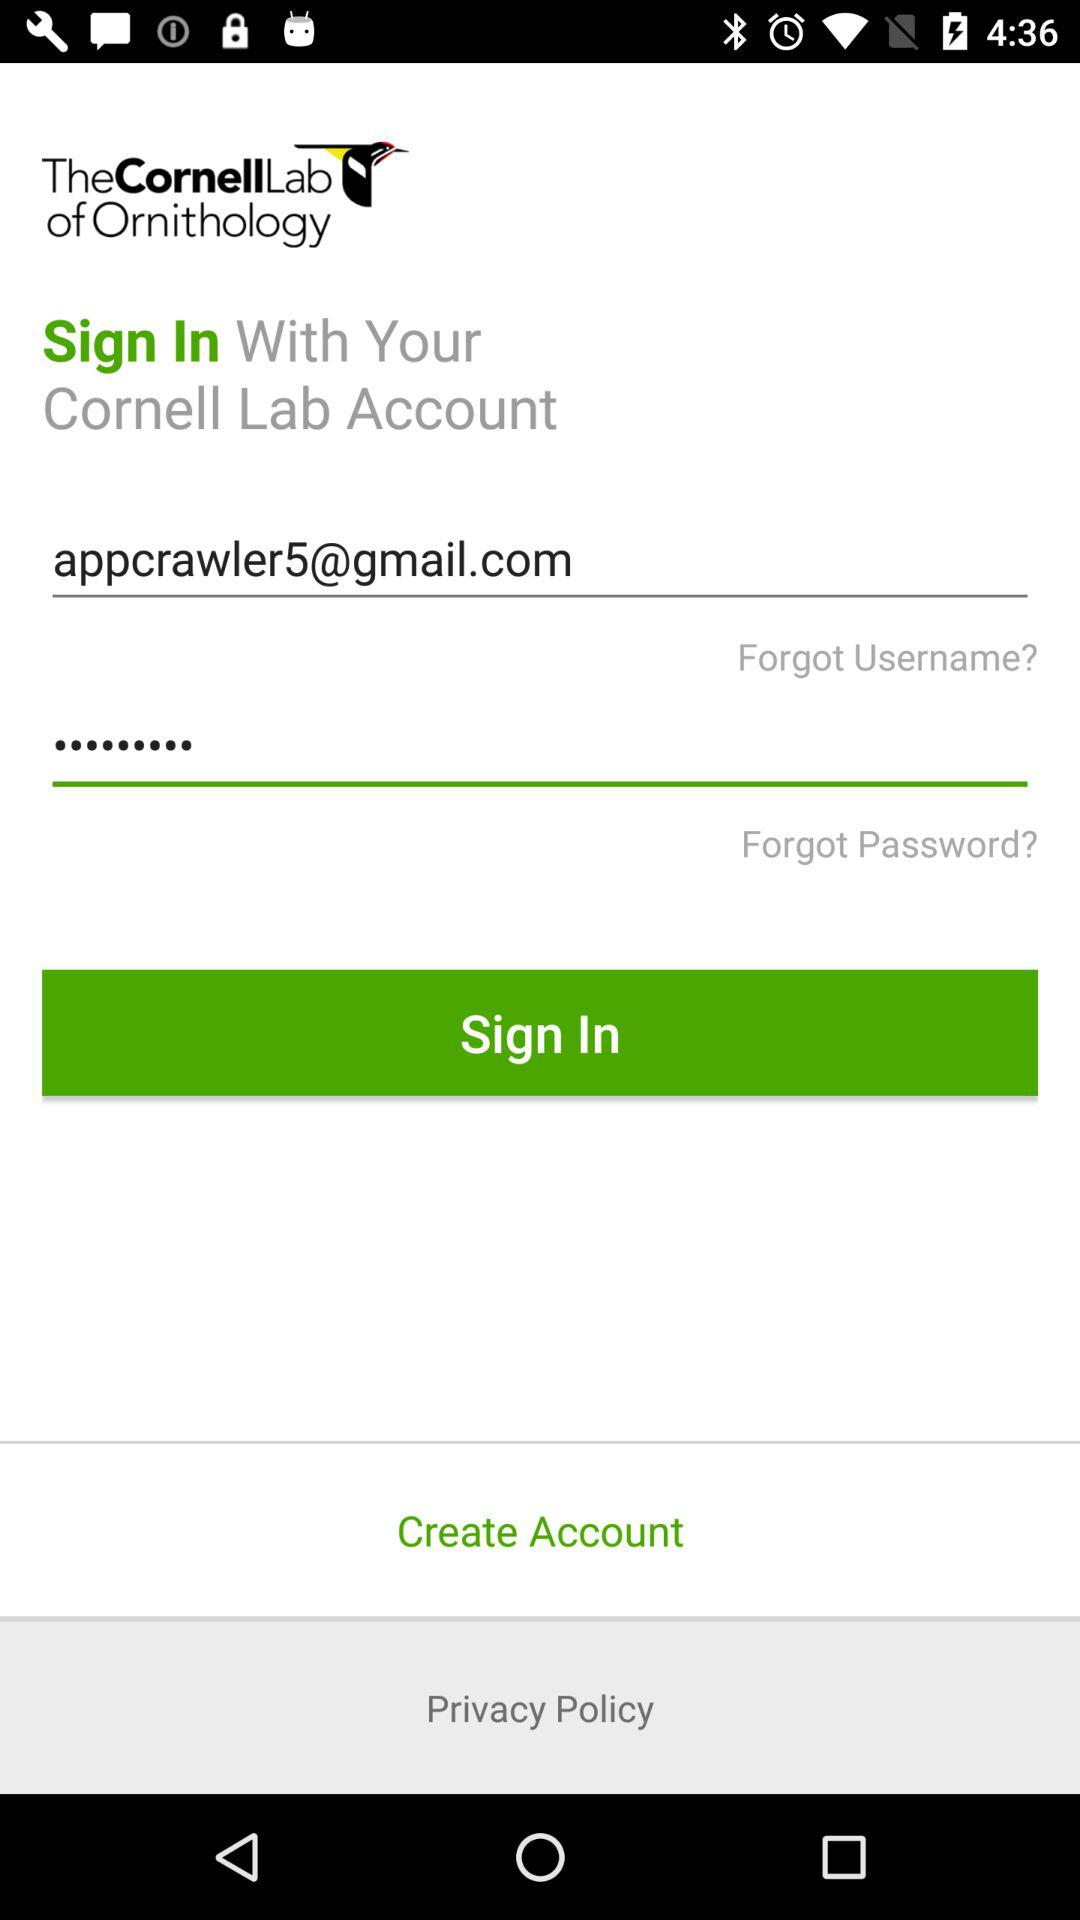What is the email address? The email address is appcrawler5@gmail.com. 